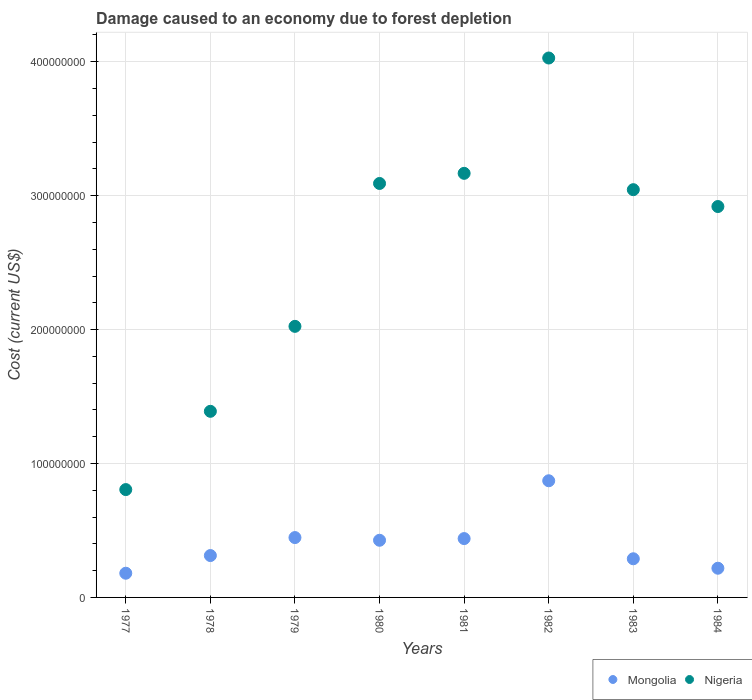Is the number of dotlines equal to the number of legend labels?
Your response must be concise. Yes. What is the cost of damage caused due to forest depletion in Nigeria in 1982?
Keep it short and to the point. 4.03e+08. Across all years, what is the maximum cost of damage caused due to forest depletion in Nigeria?
Offer a very short reply. 4.03e+08. Across all years, what is the minimum cost of damage caused due to forest depletion in Mongolia?
Offer a very short reply. 1.81e+07. In which year was the cost of damage caused due to forest depletion in Nigeria minimum?
Keep it short and to the point. 1977. What is the total cost of damage caused due to forest depletion in Nigeria in the graph?
Your answer should be compact. 2.05e+09. What is the difference between the cost of damage caused due to forest depletion in Mongolia in 1982 and that in 1984?
Your answer should be very brief. 6.53e+07. What is the difference between the cost of damage caused due to forest depletion in Nigeria in 1983 and the cost of damage caused due to forest depletion in Mongolia in 1982?
Your answer should be compact. 2.17e+08. What is the average cost of damage caused due to forest depletion in Nigeria per year?
Your response must be concise. 2.56e+08. In the year 1977, what is the difference between the cost of damage caused due to forest depletion in Nigeria and cost of damage caused due to forest depletion in Mongolia?
Offer a terse response. 6.25e+07. In how many years, is the cost of damage caused due to forest depletion in Mongolia greater than 20000000 US$?
Offer a terse response. 7. What is the ratio of the cost of damage caused due to forest depletion in Nigeria in 1980 to that in 1981?
Offer a very short reply. 0.98. Is the difference between the cost of damage caused due to forest depletion in Nigeria in 1977 and 1983 greater than the difference between the cost of damage caused due to forest depletion in Mongolia in 1977 and 1983?
Your answer should be very brief. No. What is the difference between the highest and the second highest cost of damage caused due to forest depletion in Nigeria?
Make the answer very short. 8.61e+07. What is the difference between the highest and the lowest cost of damage caused due to forest depletion in Mongolia?
Your response must be concise. 6.90e+07. In how many years, is the cost of damage caused due to forest depletion in Nigeria greater than the average cost of damage caused due to forest depletion in Nigeria taken over all years?
Your answer should be very brief. 5. Is the sum of the cost of damage caused due to forest depletion in Nigeria in 1978 and 1983 greater than the maximum cost of damage caused due to forest depletion in Mongolia across all years?
Provide a short and direct response. Yes. Does the cost of damage caused due to forest depletion in Mongolia monotonically increase over the years?
Keep it short and to the point. No. Is the cost of damage caused due to forest depletion in Mongolia strictly less than the cost of damage caused due to forest depletion in Nigeria over the years?
Your answer should be very brief. Yes. How many years are there in the graph?
Ensure brevity in your answer.  8. Where does the legend appear in the graph?
Offer a terse response. Bottom right. How are the legend labels stacked?
Your response must be concise. Horizontal. What is the title of the graph?
Make the answer very short. Damage caused to an economy due to forest depletion. Does "Malaysia" appear as one of the legend labels in the graph?
Offer a very short reply. No. What is the label or title of the X-axis?
Provide a short and direct response. Years. What is the label or title of the Y-axis?
Your answer should be very brief. Cost (current US$). What is the Cost (current US$) in Mongolia in 1977?
Make the answer very short. 1.81e+07. What is the Cost (current US$) of Nigeria in 1977?
Ensure brevity in your answer.  8.05e+07. What is the Cost (current US$) in Mongolia in 1978?
Offer a very short reply. 3.13e+07. What is the Cost (current US$) in Nigeria in 1978?
Make the answer very short. 1.39e+08. What is the Cost (current US$) of Mongolia in 1979?
Provide a short and direct response. 4.47e+07. What is the Cost (current US$) of Nigeria in 1979?
Offer a very short reply. 2.02e+08. What is the Cost (current US$) of Mongolia in 1980?
Your answer should be compact. 4.27e+07. What is the Cost (current US$) in Nigeria in 1980?
Keep it short and to the point. 3.09e+08. What is the Cost (current US$) of Mongolia in 1981?
Provide a succinct answer. 4.39e+07. What is the Cost (current US$) of Nigeria in 1981?
Provide a succinct answer. 3.17e+08. What is the Cost (current US$) in Mongolia in 1982?
Provide a short and direct response. 8.71e+07. What is the Cost (current US$) of Nigeria in 1982?
Give a very brief answer. 4.03e+08. What is the Cost (current US$) in Mongolia in 1983?
Offer a terse response. 2.89e+07. What is the Cost (current US$) in Nigeria in 1983?
Your answer should be compact. 3.04e+08. What is the Cost (current US$) of Mongolia in 1984?
Keep it short and to the point. 2.18e+07. What is the Cost (current US$) of Nigeria in 1984?
Offer a very short reply. 2.92e+08. Across all years, what is the maximum Cost (current US$) in Mongolia?
Ensure brevity in your answer.  8.71e+07. Across all years, what is the maximum Cost (current US$) of Nigeria?
Your answer should be very brief. 4.03e+08. Across all years, what is the minimum Cost (current US$) of Mongolia?
Your answer should be compact. 1.81e+07. Across all years, what is the minimum Cost (current US$) in Nigeria?
Your response must be concise. 8.05e+07. What is the total Cost (current US$) in Mongolia in the graph?
Your response must be concise. 3.18e+08. What is the total Cost (current US$) in Nigeria in the graph?
Ensure brevity in your answer.  2.05e+09. What is the difference between the Cost (current US$) of Mongolia in 1977 and that in 1978?
Provide a short and direct response. -1.32e+07. What is the difference between the Cost (current US$) of Nigeria in 1977 and that in 1978?
Your response must be concise. -5.84e+07. What is the difference between the Cost (current US$) of Mongolia in 1977 and that in 1979?
Your response must be concise. -2.66e+07. What is the difference between the Cost (current US$) of Nigeria in 1977 and that in 1979?
Your answer should be compact. -1.22e+08. What is the difference between the Cost (current US$) of Mongolia in 1977 and that in 1980?
Ensure brevity in your answer.  -2.46e+07. What is the difference between the Cost (current US$) of Nigeria in 1977 and that in 1980?
Your answer should be compact. -2.29e+08. What is the difference between the Cost (current US$) in Mongolia in 1977 and that in 1981?
Give a very brief answer. -2.59e+07. What is the difference between the Cost (current US$) of Nigeria in 1977 and that in 1981?
Provide a succinct answer. -2.36e+08. What is the difference between the Cost (current US$) in Mongolia in 1977 and that in 1982?
Provide a succinct answer. -6.90e+07. What is the difference between the Cost (current US$) of Nigeria in 1977 and that in 1982?
Your answer should be very brief. -3.22e+08. What is the difference between the Cost (current US$) in Mongolia in 1977 and that in 1983?
Provide a succinct answer. -1.08e+07. What is the difference between the Cost (current US$) in Nigeria in 1977 and that in 1983?
Make the answer very short. -2.24e+08. What is the difference between the Cost (current US$) in Mongolia in 1977 and that in 1984?
Your response must be concise. -3.74e+06. What is the difference between the Cost (current US$) of Nigeria in 1977 and that in 1984?
Provide a short and direct response. -2.11e+08. What is the difference between the Cost (current US$) of Mongolia in 1978 and that in 1979?
Provide a succinct answer. -1.34e+07. What is the difference between the Cost (current US$) of Nigeria in 1978 and that in 1979?
Give a very brief answer. -6.34e+07. What is the difference between the Cost (current US$) of Mongolia in 1978 and that in 1980?
Offer a very short reply. -1.14e+07. What is the difference between the Cost (current US$) in Nigeria in 1978 and that in 1980?
Keep it short and to the point. -1.70e+08. What is the difference between the Cost (current US$) in Mongolia in 1978 and that in 1981?
Keep it short and to the point. -1.27e+07. What is the difference between the Cost (current US$) of Nigeria in 1978 and that in 1981?
Your response must be concise. -1.78e+08. What is the difference between the Cost (current US$) in Mongolia in 1978 and that in 1982?
Offer a terse response. -5.58e+07. What is the difference between the Cost (current US$) in Nigeria in 1978 and that in 1982?
Make the answer very short. -2.64e+08. What is the difference between the Cost (current US$) of Mongolia in 1978 and that in 1983?
Your response must be concise. 2.40e+06. What is the difference between the Cost (current US$) in Nigeria in 1978 and that in 1983?
Ensure brevity in your answer.  -1.66e+08. What is the difference between the Cost (current US$) in Mongolia in 1978 and that in 1984?
Make the answer very short. 9.46e+06. What is the difference between the Cost (current US$) in Nigeria in 1978 and that in 1984?
Make the answer very short. -1.53e+08. What is the difference between the Cost (current US$) of Mongolia in 1979 and that in 1980?
Offer a terse response. 2.01e+06. What is the difference between the Cost (current US$) of Nigeria in 1979 and that in 1980?
Your answer should be compact. -1.07e+08. What is the difference between the Cost (current US$) in Mongolia in 1979 and that in 1981?
Offer a very short reply. 7.55e+05. What is the difference between the Cost (current US$) in Nigeria in 1979 and that in 1981?
Provide a short and direct response. -1.14e+08. What is the difference between the Cost (current US$) in Mongolia in 1979 and that in 1982?
Offer a terse response. -4.24e+07. What is the difference between the Cost (current US$) in Nigeria in 1979 and that in 1982?
Keep it short and to the point. -2.00e+08. What is the difference between the Cost (current US$) of Mongolia in 1979 and that in 1983?
Keep it short and to the point. 1.58e+07. What is the difference between the Cost (current US$) in Nigeria in 1979 and that in 1983?
Provide a succinct answer. -1.02e+08. What is the difference between the Cost (current US$) in Mongolia in 1979 and that in 1984?
Keep it short and to the point. 2.29e+07. What is the difference between the Cost (current US$) of Nigeria in 1979 and that in 1984?
Your response must be concise. -8.95e+07. What is the difference between the Cost (current US$) of Mongolia in 1980 and that in 1981?
Your response must be concise. -1.26e+06. What is the difference between the Cost (current US$) of Nigeria in 1980 and that in 1981?
Keep it short and to the point. -7.56e+06. What is the difference between the Cost (current US$) in Mongolia in 1980 and that in 1982?
Your answer should be compact. -4.44e+07. What is the difference between the Cost (current US$) of Nigeria in 1980 and that in 1982?
Your answer should be compact. -9.37e+07. What is the difference between the Cost (current US$) of Mongolia in 1980 and that in 1983?
Ensure brevity in your answer.  1.38e+07. What is the difference between the Cost (current US$) in Nigeria in 1980 and that in 1983?
Keep it short and to the point. 4.64e+06. What is the difference between the Cost (current US$) of Mongolia in 1980 and that in 1984?
Make the answer very short. 2.09e+07. What is the difference between the Cost (current US$) in Nigeria in 1980 and that in 1984?
Offer a very short reply. 1.72e+07. What is the difference between the Cost (current US$) of Mongolia in 1981 and that in 1982?
Your response must be concise. -4.32e+07. What is the difference between the Cost (current US$) in Nigeria in 1981 and that in 1982?
Your answer should be compact. -8.61e+07. What is the difference between the Cost (current US$) in Mongolia in 1981 and that in 1983?
Your response must be concise. 1.51e+07. What is the difference between the Cost (current US$) of Nigeria in 1981 and that in 1983?
Provide a short and direct response. 1.22e+07. What is the difference between the Cost (current US$) of Mongolia in 1981 and that in 1984?
Give a very brief answer. 2.21e+07. What is the difference between the Cost (current US$) in Nigeria in 1981 and that in 1984?
Your answer should be compact. 2.48e+07. What is the difference between the Cost (current US$) in Mongolia in 1982 and that in 1983?
Offer a terse response. 5.82e+07. What is the difference between the Cost (current US$) in Nigeria in 1982 and that in 1983?
Offer a terse response. 9.83e+07. What is the difference between the Cost (current US$) in Mongolia in 1982 and that in 1984?
Offer a very short reply. 6.53e+07. What is the difference between the Cost (current US$) of Nigeria in 1982 and that in 1984?
Provide a succinct answer. 1.11e+08. What is the difference between the Cost (current US$) of Mongolia in 1983 and that in 1984?
Keep it short and to the point. 7.06e+06. What is the difference between the Cost (current US$) of Nigeria in 1983 and that in 1984?
Ensure brevity in your answer.  1.26e+07. What is the difference between the Cost (current US$) in Mongolia in 1977 and the Cost (current US$) in Nigeria in 1978?
Offer a very short reply. -1.21e+08. What is the difference between the Cost (current US$) in Mongolia in 1977 and the Cost (current US$) in Nigeria in 1979?
Ensure brevity in your answer.  -1.84e+08. What is the difference between the Cost (current US$) of Mongolia in 1977 and the Cost (current US$) of Nigeria in 1980?
Give a very brief answer. -2.91e+08. What is the difference between the Cost (current US$) in Mongolia in 1977 and the Cost (current US$) in Nigeria in 1981?
Give a very brief answer. -2.99e+08. What is the difference between the Cost (current US$) in Mongolia in 1977 and the Cost (current US$) in Nigeria in 1982?
Your response must be concise. -3.85e+08. What is the difference between the Cost (current US$) of Mongolia in 1977 and the Cost (current US$) of Nigeria in 1983?
Offer a very short reply. -2.86e+08. What is the difference between the Cost (current US$) of Mongolia in 1977 and the Cost (current US$) of Nigeria in 1984?
Keep it short and to the point. -2.74e+08. What is the difference between the Cost (current US$) in Mongolia in 1978 and the Cost (current US$) in Nigeria in 1979?
Make the answer very short. -1.71e+08. What is the difference between the Cost (current US$) in Mongolia in 1978 and the Cost (current US$) in Nigeria in 1980?
Give a very brief answer. -2.78e+08. What is the difference between the Cost (current US$) in Mongolia in 1978 and the Cost (current US$) in Nigeria in 1981?
Provide a short and direct response. -2.85e+08. What is the difference between the Cost (current US$) in Mongolia in 1978 and the Cost (current US$) in Nigeria in 1982?
Provide a short and direct response. -3.72e+08. What is the difference between the Cost (current US$) of Mongolia in 1978 and the Cost (current US$) of Nigeria in 1983?
Ensure brevity in your answer.  -2.73e+08. What is the difference between the Cost (current US$) in Mongolia in 1978 and the Cost (current US$) in Nigeria in 1984?
Provide a short and direct response. -2.61e+08. What is the difference between the Cost (current US$) of Mongolia in 1979 and the Cost (current US$) of Nigeria in 1980?
Your answer should be very brief. -2.64e+08. What is the difference between the Cost (current US$) in Mongolia in 1979 and the Cost (current US$) in Nigeria in 1981?
Your answer should be compact. -2.72e+08. What is the difference between the Cost (current US$) in Mongolia in 1979 and the Cost (current US$) in Nigeria in 1982?
Provide a succinct answer. -3.58e+08. What is the difference between the Cost (current US$) in Mongolia in 1979 and the Cost (current US$) in Nigeria in 1983?
Ensure brevity in your answer.  -2.60e+08. What is the difference between the Cost (current US$) in Mongolia in 1979 and the Cost (current US$) in Nigeria in 1984?
Make the answer very short. -2.47e+08. What is the difference between the Cost (current US$) in Mongolia in 1980 and the Cost (current US$) in Nigeria in 1981?
Your answer should be compact. -2.74e+08. What is the difference between the Cost (current US$) in Mongolia in 1980 and the Cost (current US$) in Nigeria in 1982?
Make the answer very short. -3.60e+08. What is the difference between the Cost (current US$) of Mongolia in 1980 and the Cost (current US$) of Nigeria in 1983?
Provide a succinct answer. -2.62e+08. What is the difference between the Cost (current US$) of Mongolia in 1980 and the Cost (current US$) of Nigeria in 1984?
Provide a succinct answer. -2.49e+08. What is the difference between the Cost (current US$) of Mongolia in 1981 and the Cost (current US$) of Nigeria in 1982?
Offer a very short reply. -3.59e+08. What is the difference between the Cost (current US$) of Mongolia in 1981 and the Cost (current US$) of Nigeria in 1983?
Give a very brief answer. -2.61e+08. What is the difference between the Cost (current US$) of Mongolia in 1981 and the Cost (current US$) of Nigeria in 1984?
Ensure brevity in your answer.  -2.48e+08. What is the difference between the Cost (current US$) of Mongolia in 1982 and the Cost (current US$) of Nigeria in 1983?
Your response must be concise. -2.17e+08. What is the difference between the Cost (current US$) in Mongolia in 1982 and the Cost (current US$) in Nigeria in 1984?
Your response must be concise. -2.05e+08. What is the difference between the Cost (current US$) in Mongolia in 1983 and the Cost (current US$) in Nigeria in 1984?
Make the answer very short. -2.63e+08. What is the average Cost (current US$) of Mongolia per year?
Provide a short and direct response. 3.98e+07. What is the average Cost (current US$) of Nigeria per year?
Your response must be concise. 2.56e+08. In the year 1977, what is the difference between the Cost (current US$) in Mongolia and Cost (current US$) in Nigeria?
Your answer should be very brief. -6.25e+07. In the year 1978, what is the difference between the Cost (current US$) of Mongolia and Cost (current US$) of Nigeria?
Keep it short and to the point. -1.08e+08. In the year 1979, what is the difference between the Cost (current US$) in Mongolia and Cost (current US$) in Nigeria?
Offer a terse response. -1.58e+08. In the year 1980, what is the difference between the Cost (current US$) of Mongolia and Cost (current US$) of Nigeria?
Your answer should be very brief. -2.66e+08. In the year 1981, what is the difference between the Cost (current US$) of Mongolia and Cost (current US$) of Nigeria?
Your response must be concise. -2.73e+08. In the year 1982, what is the difference between the Cost (current US$) of Mongolia and Cost (current US$) of Nigeria?
Keep it short and to the point. -3.16e+08. In the year 1983, what is the difference between the Cost (current US$) in Mongolia and Cost (current US$) in Nigeria?
Keep it short and to the point. -2.76e+08. In the year 1984, what is the difference between the Cost (current US$) in Mongolia and Cost (current US$) in Nigeria?
Your answer should be compact. -2.70e+08. What is the ratio of the Cost (current US$) in Mongolia in 1977 to that in 1978?
Your response must be concise. 0.58. What is the ratio of the Cost (current US$) in Nigeria in 1977 to that in 1978?
Make the answer very short. 0.58. What is the ratio of the Cost (current US$) in Mongolia in 1977 to that in 1979?
Ensure brevity in your answer.  0.4. What is the ratio of the Cost (current US$) of Nigeria in 1977 to that in 1979?
Make the answer very short. 0.4. What is the ratio of the Cost (current US$) of Mongolia in 1977 to that in 1980?
Ensure brevity in your answer.  0.42. What is the ratio of the Cost (current US$) in Nigeria in 1977 to that in 1980?
Provide a succinct answer. 0.26. What is the ratio of the Cost (current US$) of Mongolia in 1977 to that in 1981?
Provide a succinct answer. 0.41. What is the ratio of the Cost (current US$) of Nigeria in 1977 to that in 1981?
Offer a terse response. 0.25. What is the ratio of the Cost (current US$) in Mongolia in 1977 to that in 1982?
Your response must be concise. 0.21. What is the ratio of the Cost (current US$) of Nigeria in 1977 to that in 1982?
Keep it short and to the point. 0.2. What is the ratio of the Cost (current US$) of Mongolia in 1977 to that in 1983?
Keep it short and to the point. 0.63. What is the ratio of the Cost (current US$) in Nigeria in 1977 to that in 1983?
Give a very brief answer. 0.26. What is the ratio of the Cost (current US$) of Mongolia in 1977 to that in 1984?
Provide a short and direct response. 0.83. What is the ratio of the Cost (current US$) of Nigeria in 1977 to that in 1984?
Your answer should be compact. 0.28. What is the ratio of the Cost (current US$) in Mongolia in 1978 to that in 1979?
Your response must be concise. 0.7. What is the ratio of the Cost (current US$) in Nigeria in 1978 to that in 1979?
Keep it short and to the point. 0.69. What is the ratio of the Cost (current US$) of Mongolia in 1978 to that in 1980?
Your answer should be compact. 0.73. What is the ratio of the Cost (current US$) of Nigeria in 1978 to that in 1980?
Your response must be concise. 0.45. What is the ratio of the Cost (current US$) of Mongolia in 1978 to that in 1981?
Your answer should be very brief. 0.71. What is the ratio of the Cost (current US$) of Nigeria in 1978 to that in 1981?
Provide a succinct answer. 0.44. What is the ratio of the Cost (current US$) of Mongolia in 1978 to that in 1982?
Give a very brief answer. 0.36. What is the ratio of the Cost (current US$) in Nigeria in 1978 to that in 1982?
Provide a succinct answer. 0.34. What is the ratio of the Cost (current US$) in Nigeria in 1978 to that in 1983?
Ensure brevity in your answer.  0.46. What is the ratio of the Cost (current US$) in Mongolia in 1978 to that in 1984?
Your response must be concise. 1.43. What is the ratio of the Cost (current US$) in Nigeria in 1978 to that in 1984?
Your answer should be very brief. 0.48. What is the ratio of the Cost (current US$) of Mongolia in 1979 to that in 1980?
Your answer should be very brief. 1.05. What is the ratio of the Cost (current US$) of Nigeria in 1979 to that in 1980?
Keep it short and to the point. 0.65. What is the ratio of the Cost (current US$) of Mongolia in 1979 to that in 1981?
Your answer should be compact. 1.02. What is the ratio of the Cost (current US$) of Nigeria in 1979 to that in 1981?
Your answer should be compact. 0.64. What is the ratio of the Cost (current US$) in Mongolia in 1979 to that in 1982?
Keep it short and to the point. 0.51. What is the ratio of the Cost (current US$) in Nigeria in 1979 to that in 1982?
Make the answer very short. 0.5. What is the ratio of the Cost (current US$) in Mongolia in 1979 to that in 1983?
Ensure brevity in your answer.  1.55. What is the ratio of the Cost (current US$) in Nigeria in 1979 to that in 1983?
Provide a succinct answer. 0.66. What is the ratio of the Cost (current US$) of Mongolia in 1979 to that in 1984?
Give a very brief answer. 2.05. What is the ratio of the Cost (current US$) of Nigeria in 1979 to that in 1984?
Your response must be concise. 0.69. What is the ratio of the Cost (current US$) in Mongolia in 1980 to that in 1981?
Your answer should be very brief. 0.97. What is the ratio of the Cost (current US$) of Nigeria in 1980 to that in 1981?
Your response must be concise. 0.98. What is the ratio of the Cost (current US$) in Mongolia in 1980 to that in 1982?
Offer a terse response. 0.49. What is the ratio of the Cost (current US$) in Nigeria in 1980 to that in 1982?
Your answer should be compact. 0.77. What is the ratio of the Cost (current US$) in Mongolia in 1980 to that in 1983?
Ensure brevity in your answer.  1.48. What is the ratio of the Cost (current US$) of Nigeria in 1980 to that in 1983?
Your answer should be compact. 1.02. What is the ratio of the Cost (current US$) in Mongolia in 1980 to that in 1984?
Give a very brief answer. 1.96. What is the ratio of the Cost (current US$) of Nigeria in 1980 to that in 1984?
Provide a short and direct response. 1.06. What is the ratio of the Cost (current US$) of Mongolia in 1981 to that in 1982?
Your answer should be very brief. 0.5. What is the ratio of the Cost (current US$) in Nigeria in 1981 to that in 1982?
Offer a very short reply. 0.79. What is the ratio of the Cost (current US$) in Mongolia in 1981 to that in 1983?
Your response must be concise. 1.52. What is the ratio of the Cost (current US$) of Nigeria in 1981 to that in 1983?
Your response must be concise. 1.04. What is the ratio of the Cost (current US$) in Mongolia in 1981 to that in 1984?
Your answer should be very brief. 2.02. What is the ratio of the Cost (current US$) in Nigeria in 1981 to that in 1984?
Provide a succinct answer. 1.08. What is the ratio of the Cost (current US$) of Mongolia in 1982 to that in 1983?
Your answer should be compact. 3.02. What is the ratio of the Cost (current US$) in Nigeria in 1982 to that in 1983?
Keep it short and to the point. 1.32. What is the ratio of the Cost (current US$) in Mongolia in 1982 to that in 1984?
Keep it short and to the point. 4. What is the ratio of the Cost (current US$) of Nigeria in 1982 to that in 1984?
Your answer should be very brief. 1.38. What is the ratio of the Cost (current US$) in Mongolia in 1983 to that in 1984?
Keep it short and to the point. 1.32. What is the ratio of the Cost (current US$) of Nigeria in 1983 to that in 1984?
Give a very brief answer. 1.04. What is the difference between the highest and the second highest Cost (current US$) in Mongolia?
Keep it short and to the point. 4.24e+07. What is the difference between the highest and the second highest Cost (current US$) of Nigeria?
Provide a succinct answer. 8.61e+07. What is the difference between the highest and the lowest Cost (current US$) in Mongolia?
Give a very brief answer. 6.90e+07. What is the difference between the highest and the lowest Cost (current US$) in Nigeria?
Provide a succinct answer. 3.22e+08. 